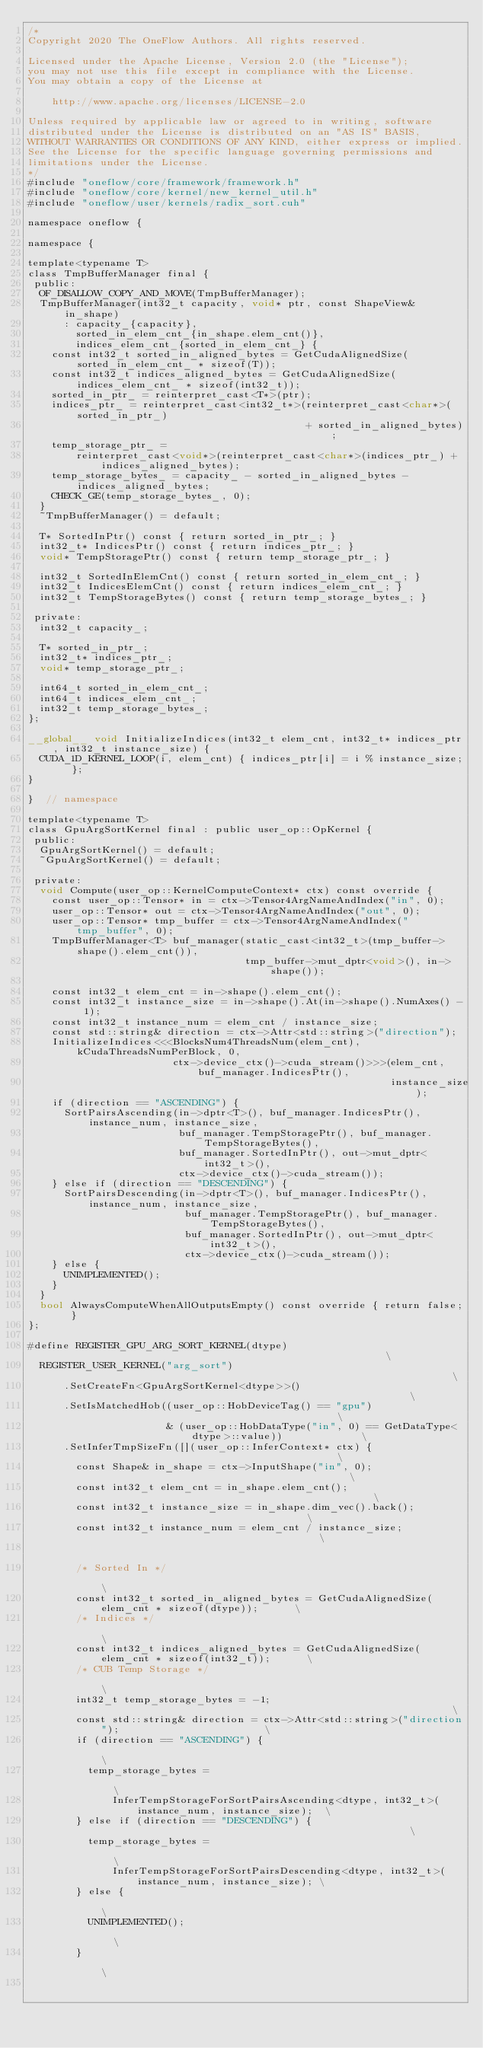<code> <loc_0><loc_0><loc_500><loc_500><_Cuda_>/*
Copyright 2020 The OneFlow Authors. All rights reserved.

Licensed under the Apache License, Version 2.0 (the "License");
you may not use this file except in compliance with the License.
You may obtain a copy of the License at

    http://www.apache.org/licenses/LICENSE-2.0

Unless required by applicable law or agreed to in writing, software
distributed under the License is distributed on an "AS IS" BASIS,
WITHOUT WARRANTIES OR CONDITIONS OF ANY KIND, either express or implied.
See the License for the specific language governing permissions and
limitations under the License.
*/
#include "oneflow/core/framework/framework.h"
#include "oneflow/core/kernel/new_kernel_util.h"
#include "oneflow/user/kernels/radix_sort.cuh"

namespace oneflow {

namespace {

template<typename T>
class TmpBufferManager final {
 public:
  OF_DISALLOW_COPY_AND_MOVE(TmpBufferManager);
  TmpBufferManager(int32_t capacity, void* ptr, const ShapeView& in_shape)
      : capacity_{capacity},
        sorted_in_elem_cnt_{in_shape.elem_cnt()},
        indices_elem_cnt_{sorted_in_elem_cnt_} {
    const int32_t sorted_in_aligned_bytes = GetCudaAlignedSize(sorted_in_elem_cnt_ * sizeof(T));
    const int32_t indices_aligned_bytes = GetCudaAlignedSize(indices_elem_cnt_ * sizeof(int32_t));
    sorted_in_ptr_ = reinterpret_cast<T*>(ptr);
    indices_ptr_ = reinterpret_cast<int32_t*>(reinterpret_cast<char*>(sorted_in_ptr_)
                                              + sorted_in_aligned_bytes);
    temp_storage_ptr_ =
        reinterpret_cast<void*>(reinterpret_cast<char*>(indices_ptr_) + indices_aligned_bytes);
    temp_storage_bytes_ = capacity_ - sorted_in_aligned_bytes - indices_aligned_bytes;
    CHECK_GE(temp_storage_bytes_, 0);
  }
  ~TmpBufferManager() = default;

  T* SortedInPtr() const { return sorted_in_ptr_; }
  int32_t* IndicesPtr() const { return indices_ptr_; }
  void* TempStoragePtr() const { return temp_storage_ptr_; }

  int32_t SortedInElemCnt() const { return sorted_in_elem_cnt_; }
  int32_t IndicesElemCnt() const { return indices_elem_cnt_; }
  int32_t TempStorageBytes() const { return temp_storage_bytes_; }

 private:
  int32_t capacity_;

  T* sorted_in_ptr_;
  int32_t* indices_ptr_;
  void* temp_storage_ptr_;

  int64_t sorted_in_elem_cnt_;
  int64_t indices_elem_cnt_;
  int32_t temp_storage_bytes_;
};

__global__ void InitializeIndices(int32_t elem_cnt, int32_t* indices_ptr, int32_t instance_size) {
  CUDA_1D_KERNEL_LOOP(i, elem_cnt) { indices_ptr[i] = i % instance_size; };
}

}  // namespace

template<typename T>
class GpuArgSortKernel final : public user_op::OpKernel {
 public:
  GpuArgSortKernel() = default;
  ~GpuArgSortKernel() = default;

 private:
  void Compute(user_op::KernelComputeContext* ctx) const override {
    const user_op::Tensor* in = ctx->Tensor4ArgNameAndIndex("in", 0);
    user_op::Tensor* out = ctx->Tensor4ArgNameAndIndex("out", 0);
    user_op::Tensor* tmp_buffer = ctx->Tensor4ArgNameAndIndex("tmp_buffer", 0);
    TmpBufferManager<T> buf_manager(static_cast<int32_t>(tmp_buffer->shape().elem_cnt()),
                                    tmp_buffer->mut_dptr<void>(), in->shape());

    const int32_t elem_cnt = in->shape().elem_cnt();
    const int32_t instance_size = in->shape().At(in->shape().NumAxes() - 1);
    const int32_t instance_num = elem_cnt / instance_size;
    const std::string& direction = ctx->Attr<std::string>("direction");
    InitializeIndices<<<BlocksNum4ThreadsNum(elem_cnt), kCudaThreadsNumPerBlock, 0,
                        ctx->device_ctx()->cuda_stream()>>>(elem_cnt, buf_manager.IndicesPtr(),
                                                            instance_size);
    if (direction == "ASCENDING") {
      SortPairsAscending(in->dptr<T>(), buf_manager.IndicesPtr(), instance_num, instance_size,
                         buf_manager.TempStoragePtr(), buf_manager.TempStorageBytes(),
                         buf_manager.SortedInPtr(), out->mut_dptr<int32_t>(),
                         ctx->device_ctx()->cuda_stream());
    } else if (direction == "DESCENDING") {
      SortPairsDescending(in->dptr<T>(), buf_manager.IndicesPtr(), instance_num, instance_size,
                          buf_manager.TempStoragePtr(), buf_manager.TempStorageBytes(),
                          buf_manager.SortedInPtr(), out->mut_dptr<int32_t>(),
                          ctx->device_ctx()->cuda_stream());
    } else {
      UNIMPLEMENTED();
    }
  }
  bool AlwaysComputeWhenAllOutputsEmpty() const override { return false; }
};

#define REGISTER_GPU_ARG_SORT_KERNEL(dtype)                                                        \
  REGISTER_USER_KERNEL("arg_sort")                                                                 \
      .SetCreateFn<GpuArgSortKernel<dtype>>()                                                      \
      .SetIsMatchedHob((user_op::HobDeviceTag() == "gpu")                                          \
                       & (user_op::HobDataType("in", 0) == GetDataType<dtype>::value))             \
      .SetInferTmpSizeFn([](user_op::InferContext* ctx) {                                          \
        const Shape& in_shape = ctx->InputShape("in", 0);                                          \
        const int32_t elem_cnt = in_shape.elem_cnt();                                              \
        const int32_t instance_size = in_shape.dim_vec().back();                                   \
        const int32_t instance_num = elem_cnt / instance_size;                                     \
                                                                                                   \
        /* Sorted In */                                                                            \
        const int32_t sorted_in_aligned_bytes = GetCudaAlignedSize(elem_cnt * sizeof(dtype));      \
        /* Indices */                                                                              \
        const int32_t indices_aligned_bytes = GetCudaAlignedSize(elem_cnt * sizeof(int32_t));      \
        /* CUB Temp Storage */                                                                     \
        int32_t temp_storage_bytes = -1;                                                           \
        const std::string& direction = ctx->Attr<std::string>("direction");                        \
        if (direction == "ASCENDING") {                                                            \
          temp_storage_bytes =                                                                     \
              InferTempStorageForSortPairsAscending<dtype, int32_t>(instance_num, instance_size);  \
        } else if (direction == "DESCENDING") {                                                    \
          temp_storage_bytes =                                                                     \
              InferTempStorageForSortPairsDescending<dtype, int32_t>(instance_num, instance_size); \
        } else {                                                                                   \
          UNIMPLEMENTED();                                                                         \
        }                                                                                          \
                                                                                                   \</code> 